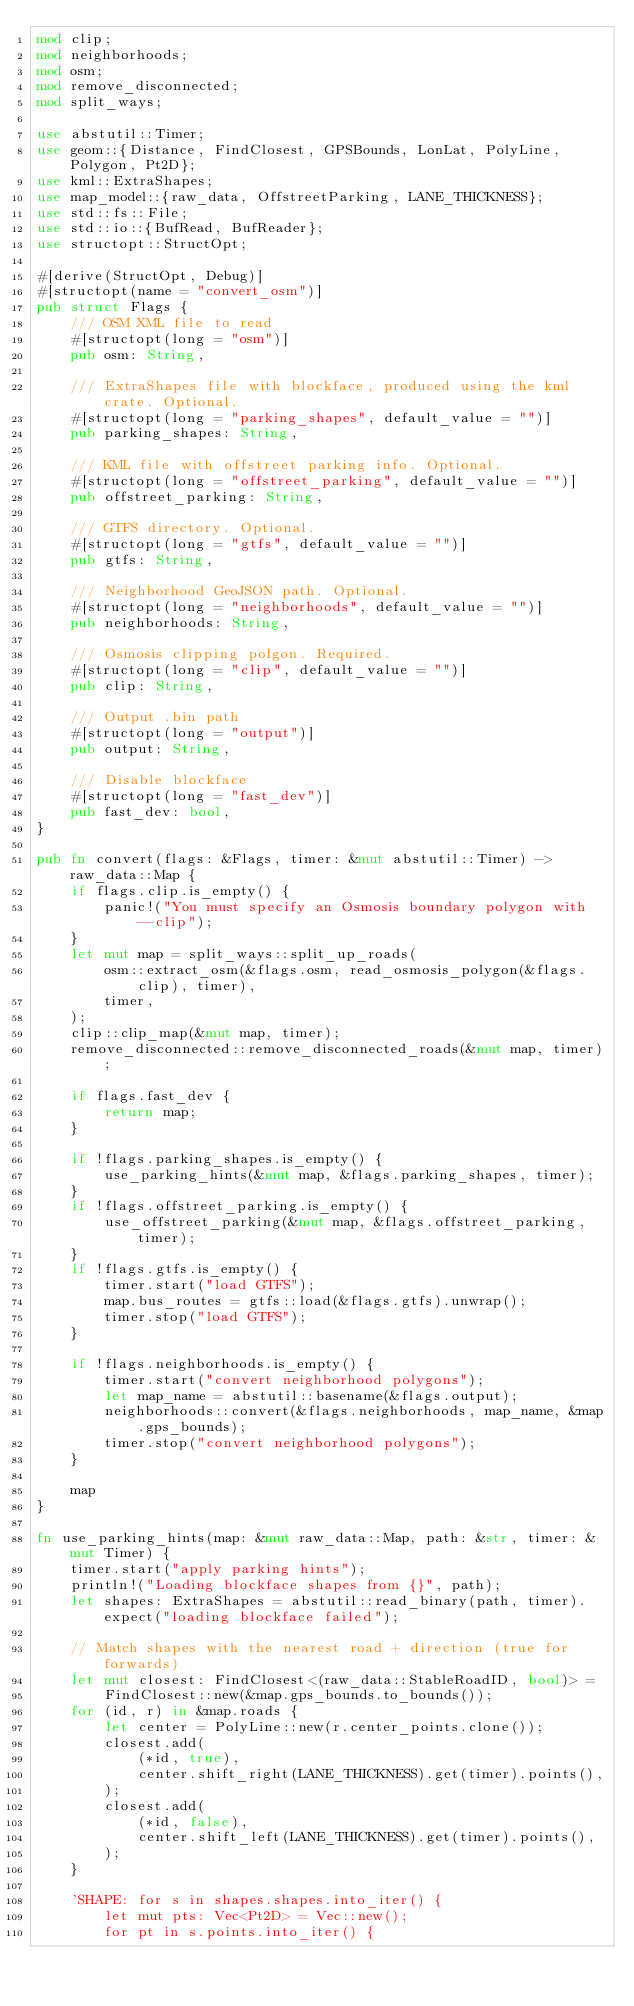<code> <loc_0><loc_0><loc_500><loc_500><_Rust_>mod clip;
mod neighborhoods;
mod osm;
mod remove_disconnected;
mod split_ways;

use abstutil::Timer;
use geom::{Distance, FindClosest, GPSBounds, LonLat, PolyLine, Polygon, Pt2D};
use kml::ExtraShapes;
use map_model::{raw_data, OffstreetParking, LANE_THICKNESS};
use std::fs::File;
use std::io::{BufRead, BufReader};
use structopt::StructOpt;

#[derive(StructOpt, Debug)]
#[structopt(name = "convert_osm")]
pub struct Flags {
    /// OSM XML file to read
    #[structopt(long = "osm")]
    pub osm: String,

    /// ExtraShapes file with blockface, produced using the kml crate. Optional.
    #[structopt(long = "parking_shapes", default_value = "")]
    pub parking_shapes: String,

    /// KML file with offstreet parking info. Optional.
    #[structopt(long = "offstreet_parking", default_value = "")]
    pub offstreet_parking: String,

    /// GTFS directory. Optional.
    #[structopt(long = "gtfs", default_value = "")]
    pub gtfs: String,

    /// Neighborhood GeoJSON path. Optional.
    #[structopt(long = "neighborhoods", default_value = "")]
    pub neighborhoods: String,

    /// Osmosis clipping polgon. Required.
    #[structopt(long = "clip", default_value = "")]
    pub clip: String,

    /// Output .bin path
    #[structopt(long = "output")]
    pub output: String,

    /// Disable blockface
    #[structopt(long = "fast_dev")]
    pub fast_dev: bool,
}

pub fn convert(flags: &Flags, timer: &mut abstutil::Timer) -> raw_data::Map {
    if flags.clip.is_empty() {
        panic!("You must specify an Osmosis boundary polygon with --clip");
    }
    let mut map = split_ways::split_up_roads(
        osm::extract_osm(&flags.osm, read_osmosis_polygon(&flags.clip), timer),
        timer,
    );
    clip::clip_map(&mut map, timer);
    remove_disconnected::remove_disconnected_roads(&mut map, timer);

    if flags.fast_dev {
        return map;
    }

    if !flags.parking_shapes.is_empty() {
        use_parking_hints(&mut map, &flags.parking_shapes, timer);
    }
    if !flags.offstreet_parking.is_empty() {
        use_offstreet_parking(&mut map, &flags.offstreet_parking, timer);
    }
    if !flags.gtfs.is_empty() {
        timer.start("load GTFS");
        map.bus_routes = gtfs::load(&flags.gtfs).unwrap();
        timer.stop("load GTFS");
    }

    if !flags.neighborhoods.is_empty() {
        timer.start("convert neighborhood polygons");
        let map_name = abstutil::basename(&flags.output);
        neighborhoods::convert(&flags.neighborhoods, map_name, &map.gps_bounds);
        timer.stop("convert neighborhood polygons");
    }

    map
}

fn use_parking_hints(map: &mut raw_data::Map, path: &str, timer: &mut Timer) {
    timer.start("apply parking hints");
    println!("Loading blockface shapes from {}", path);
    let shapes: ExtraShapes = abstutil::read_binary(path, timer).expect("loading blockface failed");

    // Match shapes with the nearest road + direction (true for forwards)
    let mut closest: FindClosest<(raw_data::StableRoadID, bool)> =
        FindClosest::new(&map.gps_bounds.to_bounds());
    for (id, r) in &map.roads {
        let center = PolyLine::new(r.center_points.clone());
        closest.add(
            (*id, true),
            center.shift_right(LANE_THICKNESS).get(timer).points(),
        );
        closest.add(
            (*id, false),
            center.shift_left(LANE_THICKNESS).get(timer).points(),
        );
    }

    'SHAPE: for s in shapes.shapes.into_iter() {
        let mut pts: Vec<Pt2D> = Vec::new();
        for pt in s.points.into_iter() {</code> 